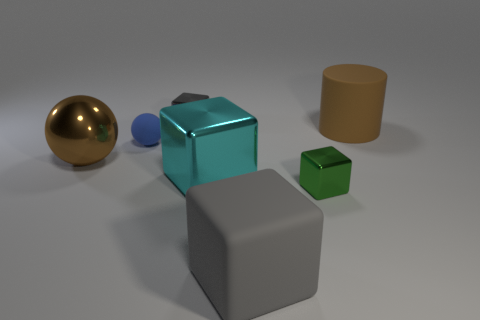Add 1 yellow things. How many objects exist? 8 Subtract all gray matte cubes. How many cubes are left? 3 Subtract all cylinders. How many objects are left? 6 Subtract all brown spheres. How many spheres are left? 1 Subtract all metallic blocks. Subtract all blue rubber objects. How many objects are left? 3 Add 1 large rubber cylinders. How many large rubber cylinders are left? 2 Add 1 big green metal spheres. How many big green metal spheres exist? 1 Subtract 0 purple cubes. How many objects are left? 7 Subtract 2 balls. How many balls are left? 0 Subtract all purple cylinders. Subtract all cyan cubes. How many cylinders are left? 1 